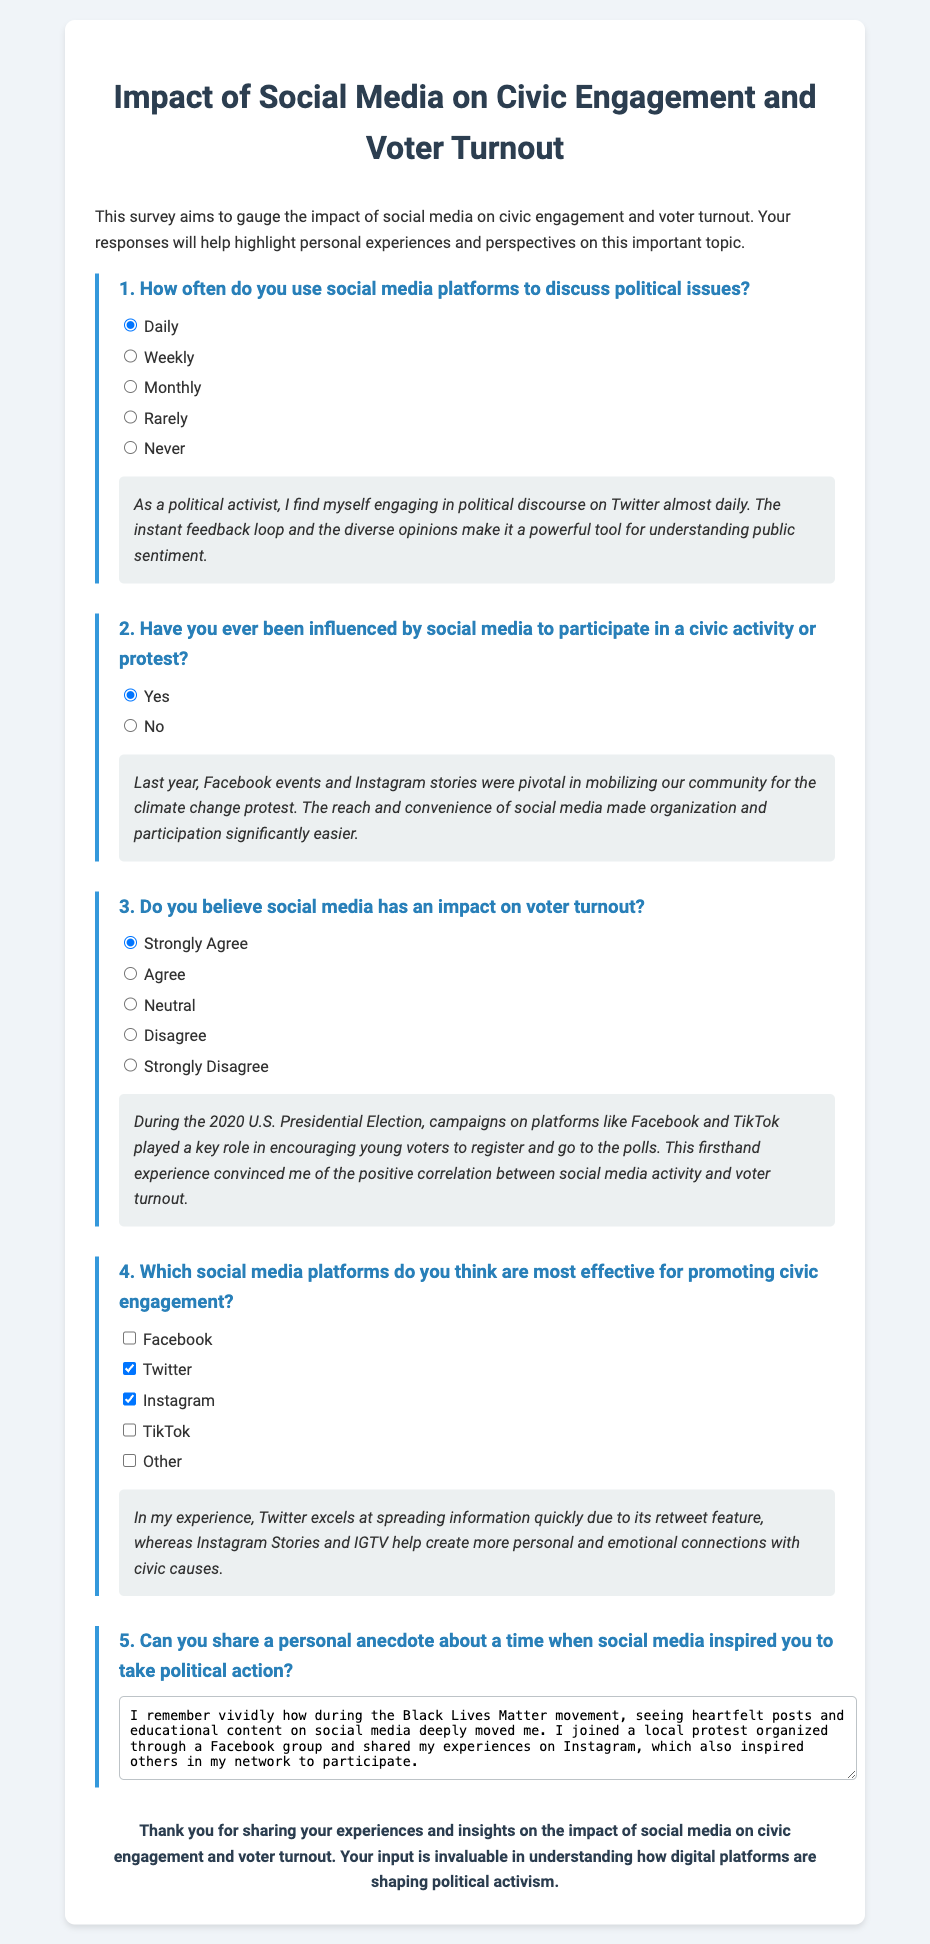What is the title of the survey? The title of the survey is presented prominently at the top of the document.
Answer: Impact of Social Media on Civic Engagement and Voter Turnout How often do survey respondents discuss political issues on social media? This information is provided in the first question of the survey, where options are presented for how often respondents engage.
Answer: Daily Which social media platform is cited as pivotal in mobilizing for a protest? The personal account in the second question mentions the effect of a social media platform on community mobilization.
Answer: Facebook What was the response to the question about social media influencing civic activities? The options given allow for discerning how many respondents felt social media influenced their civic participation.
Answer: Yes How many social media platforms are listed as options in question four? The fourth question includes multiple options related to effective social media platforms for promoting civic engagement.
Answer: Five What did the personal anecdote in question five refer to regarding social media? The anecdote shared in the fifth question emphasizes a specific social movement's impact on the individual's activism.
Answer: Black Lives Matter Which platform is noted for spreading information quickly in the personal account? A specific social media platform is highlighted in the personal account for its effectiveness in disseminating information rapidly.
Answer: Twitter What is the color of the background used for the survey container? The document specifies the background color style for the survey container.
Answer: White 